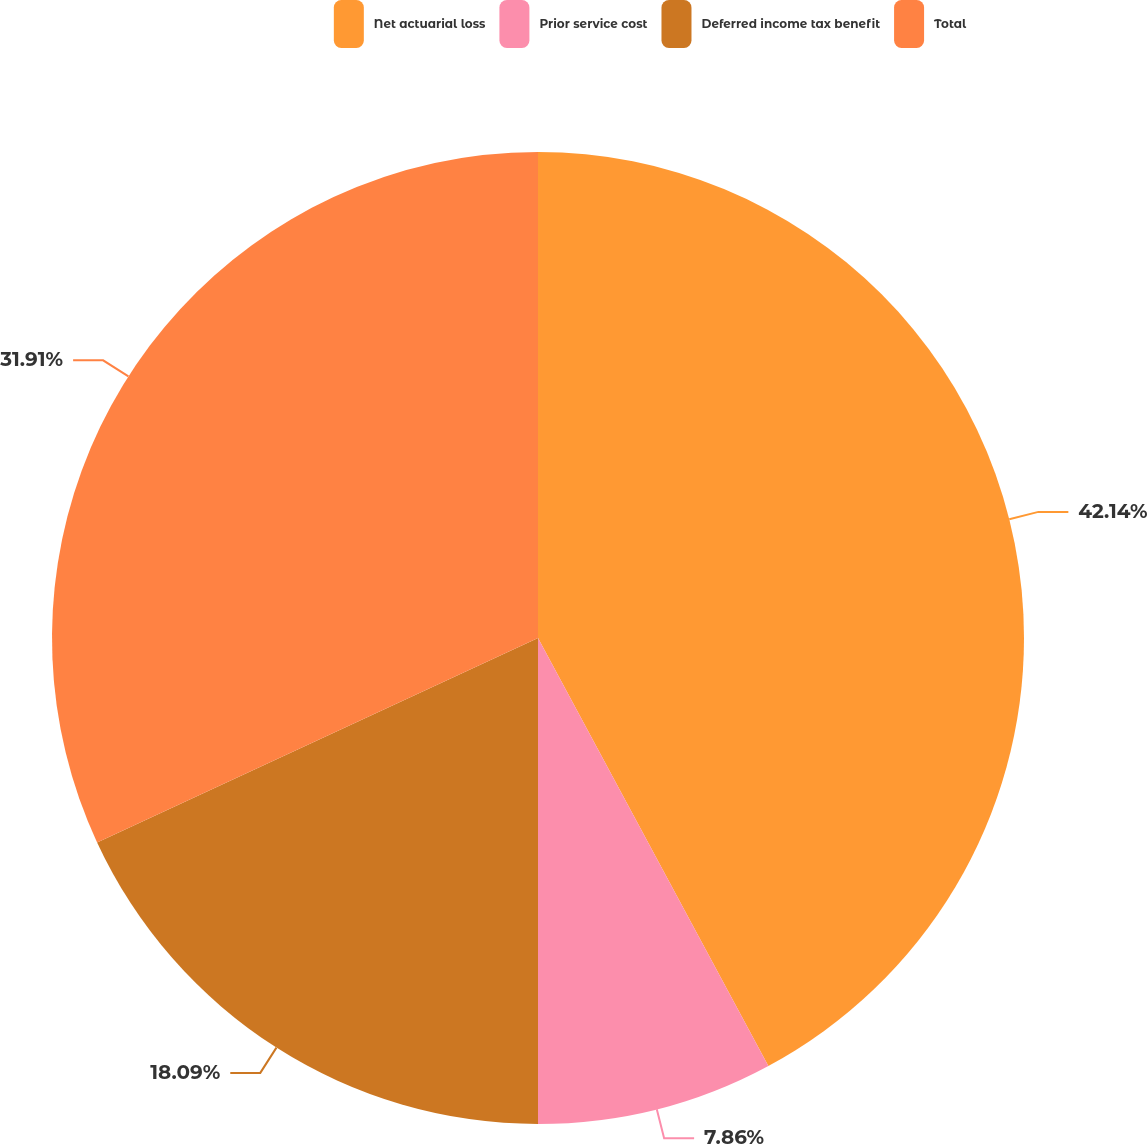Convert chart. <chart><loc_0><loc_0><loc_500><loc_500><pie_chart><fcel>Net actuarial loss<fcel>Prior service cost<fcel>Deferred income tax benefit<fcel>Total<nl><fcel>42.14%<fcel>7.86%<fcel>18.09%<fcel>31.91%<nl></chart> 